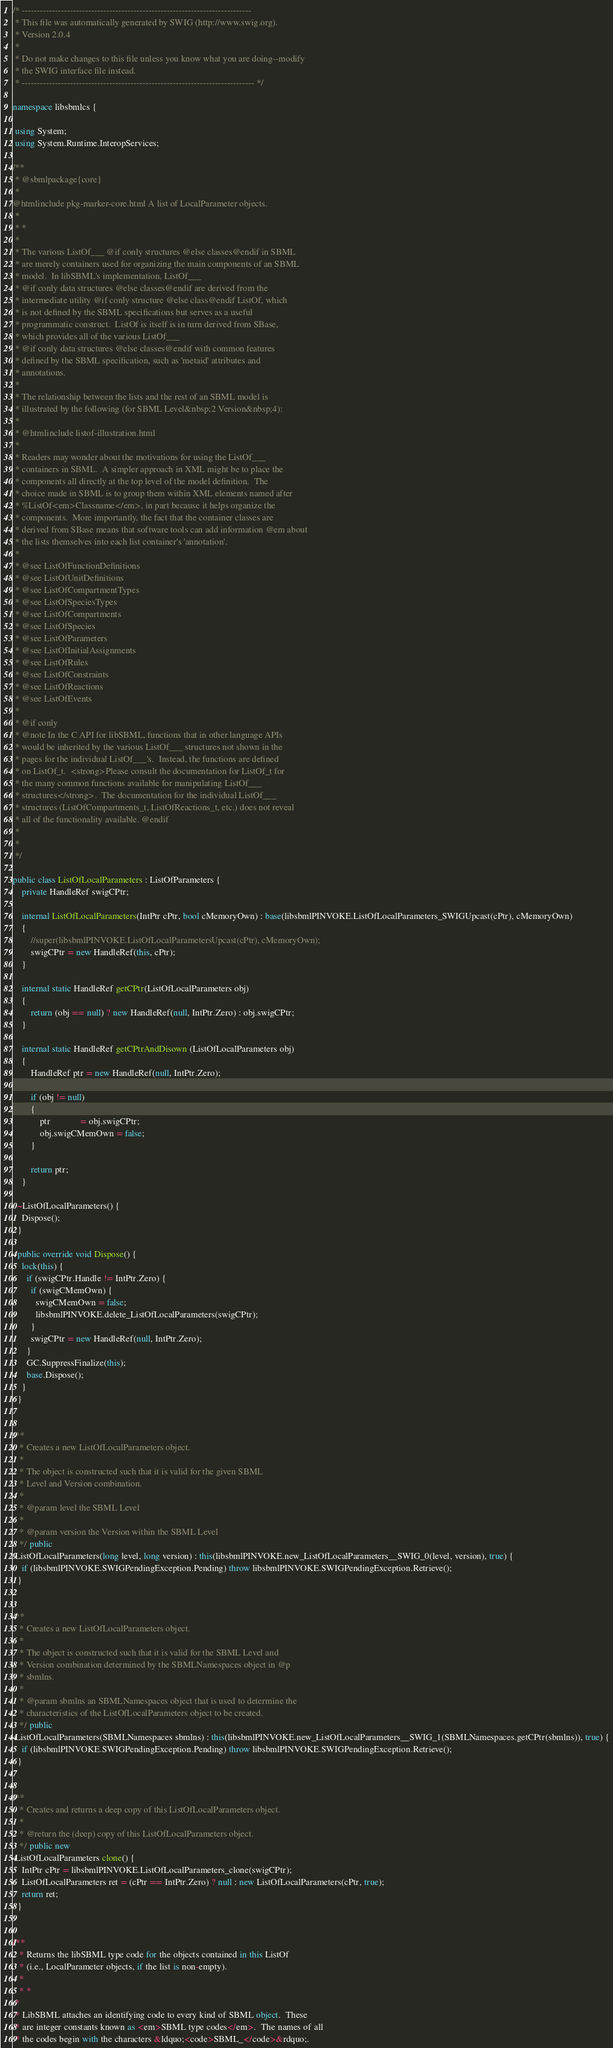<code> <loc_0><loc_0><loc_500><loc_500><_C#_>/* ----------------------------------------------------------------------------
 * This file was automatically generated by SWIG (http://www.swig.org).
 * Version 2.0.4
 *
 * Do not make changes to this file unless you know what you are doing--modify
 * the SWIG interface file instead.
 * ----------------------------------------------------------------------------- */

namespace libsbmlcs {

 using System;
 using System.Runtime.InteropServices;

/** 
 * @sbmlpackage{core}
 *
@htmlinclude pkg-marker-core.html A list of LocalParameter objects.
 * 
 * *
 * 
 * The various ListOf___ @if conly structures @else classes@endif in SBML
 * are merely containers used for organizing the main components of an SBML
 * model.  In libSBML's implementation, ListOf___
 * @if conly data structures @else classes@endif are derived from the
 * intermediate utility @if conly structure @else class@endif ListOf, which
 * is not defined by the SBML specifications but serves as a useful
 * programmatic construct.  ListOf is itself is in turn derived from SBase,
 * which provides all of the various ListOf___
 * @if conly data structures @else classes@endif with common features
 * defined by the SBML specification, such as 'metaid' attributes and
 * annotations.
 *
 * The relationship between the lists and the rest of an SBML model is
 * illustrated by the following (for SBML Level&nbsp;2 Version&nbsp;4):
 *
 * @htmlinclude listof-illustration.html
 *
 * Readers may wonder about the motivations for using the ListOf___
 * containers in SBML.  A simpler approach in XML might be to place the
 * components all directly at the top level of the model definition.  The
 * choice made in SBML is to group them within XML elements named after
 * %ListOf<em>Classname</em>, in part because it helps organize the
 * components.  More importantly, the fact that the container classes are
 * derived from SBase means that software tools can add information @em about
 * the lists themselves into each list container's 'annotation'.
 *
 * @see ListOfFunctionDefinitions
 * @see ListOfUnitDefinitions
 * @see ListOfCompartmentTypes
 * @see ListOfSpeciesTypes
 * @see ListOfCompartments
 * @see ListOfSpecies
 * @see ListOfParameters
 * @see ListOfInitialAssignments
 * @see ListOfRules
 * @see ListOfConstraints
 * @see ListOfReactions
 * @see ListOfEvents
 *
 * @if conly
 * @note In the C API for libSBML, functions that in other language APIs
 * would be inherited by the various ListOf___ structures not shown in the
 * pages for the individual ListOf___'s.  Instead, the functions are defined
 * on ListOf_t.  <strong>Please consult the documentation for ListOf_t for
 * the many common functions available for manipulating ListOf___
 * structures</strong>.  The documentation for the individual ListOf___
 * structures (ListOfCompartments_t, ListOfReactions_t, etc.) does not reveal
 * all of the functionality available. @endif
 *
 *
 */

public class ListOfLocalParameters : ListOfParameters {
	private HandleRef swigCPtr;
	
	internal ListOfLocalParameters(IntPtr cPtr, bool cMemoryOwn) : base(libsbmlPINVOKE.ListOfLocalParameters_SWIGUpcast(cPtr), cMemoryOwn)
	{
		//super(libsbmlPINVOKE.ListOfLocalParametersUpcast(cPtr), cMemoryOwn);
		swigCPtr = new HandleRef(this, cPtr);
	}
	
	internal static HandleRef getCPtr(ListOfLocalParameters obj)
	{
		return (obj == null) ? new HandleRef(null, IntPtr.Zero) : obj.swigCPtr;
	}
	
	internal static HandleRef getCPtrAndDisown (ListOfLocalParameters obj)
	{
		HandleRef ptr = new HandleRef(null, IntPtr.Zero);
		
		if (obj != null)
		{
			ptr             = obj.swigCPtr;
			obj.swigCMemOwn = false;
		}
		
		return ptr;
	}

  ~ListOfLocalParameters() {
    Dispose();
  }

  public override void Dispose() {
    lock(this) {
      if (swigCPtr.Handle != IntPtr.Zero) {
        if (swigCMemOwn) {
          swigCMemOwn = false;
          libsbmlPINVOKE.delete_ListOfLocalParameters(swigCPtr);
        }
        swigCPtr = new HandleRef(null, IntPtr.Zero);
      }
      GC.SuppressFinalize(this);
      base.Dispose();
    }
  }

  
/**
   * Creates a new ListOfLocalParameters object.
   *
   * The object is constructed such that it is valid for the given SBML
   * Level and Version combination.
   *
   * @param level the SBML Level
   * 
   * @param version the Version within the SBML Level
   */ public
 ListOfLocalParameters(long level, long version) : this(libsbmlPINVOKE.new_ListOfLocalParameters__SWIG_0(level, version), true) {
    if (libsbmlPINVOKE.SWIGPendingException.Pending) throw libsbmlPINVOKE.SWIGPendingException.Retrieve();
  }

  
/**
   * Creates a new ListOfLocalParameters object.
   *
   * The object is constructed such that it is valid for the SBML Level and
   * Version combination determined by the SBMLNamespaces object in @p
   * sbmlns.
   *
   * @param sbmlns an SBMLNamespaces object that is used to determine the
   * characteristics of the ListOfLocalParameters object to be created.
   */ public
 ListOfLocalParameters(SBMLNamespaces sbmlns) : this(libsbmlPINVOKE.new_ListOfLocalParameters__SWIG_1(SBMLNamespaces.getCPtr(sbmlns)), true) {
    if (libsbmlPINVOKE.SWIGPendingException.Pending) throw libsbmlPINVOKE.SWIGPendingException.Retrieve();
  }

  
/**
   * Creates and returns a deep copy of this ListOfLocalParameters object.
   *
   * @return the (deep) copy of this ListOfLocalParameters object.
   */ public new
 ListOfLocalParameters clone() {
    IntPtr cPtr = libsbmlPINVOKE.ListOfLocalParameters_clone(swigCPtr);
    ListOfLocalParameters ret = (cPtr == IntPtr.Zero) ? null : new ListOfLocalParameters(cPtr, true);
    return ret;
  }

  
/**
   * Returns the libSBML type code for the objects contained in this ListOf
   * (i.e., LocalParameter objects, if the list is non-empty).
   * 
   * *
 * 
 * LibSBML attaches an identifying code to every kind of SBML object.  These
 * are integer constants known as <em>SBML type codes</em>.  The names of all
 * the codes begin with the characters &ldquo;<code>SBML_</code>&rdquo;.</code> 